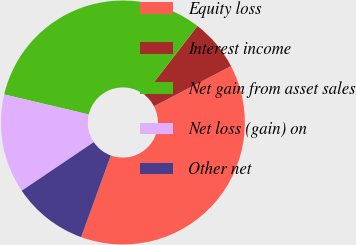Convert chart. <chart><loc_0><loc_0><loc_500><loc_500><pie_chart><fcel>Equity loss<fcel>Interest income<fcel>Net gain from asset sales<fcel>Net loss (gain) on<fcel>Other net<nl><fcel>38.21%<fcel>6.87%<fcel>31.77%<fcel>13.14%<fcel>10.0%<nl></chart> 